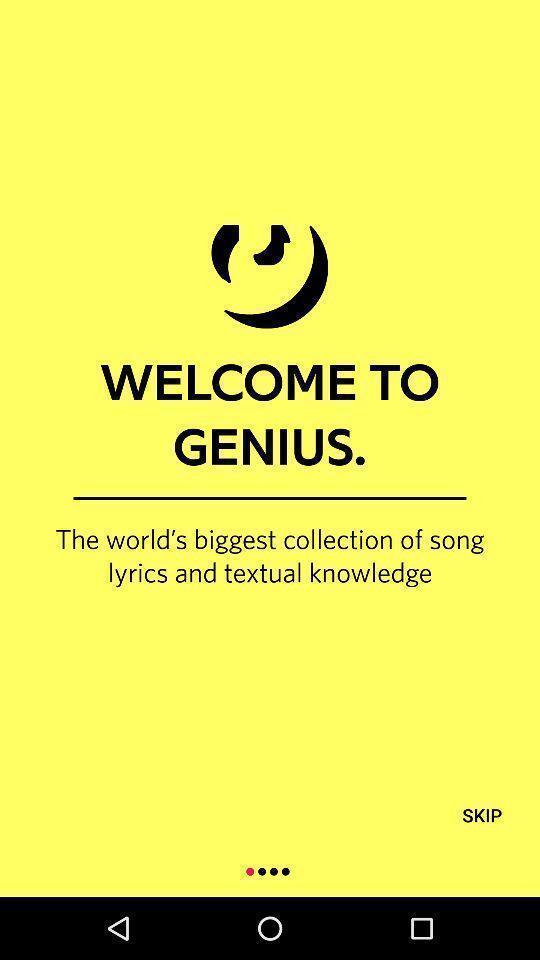Tell me about the visual elements in this screen capture. Welcome page to genius app. 